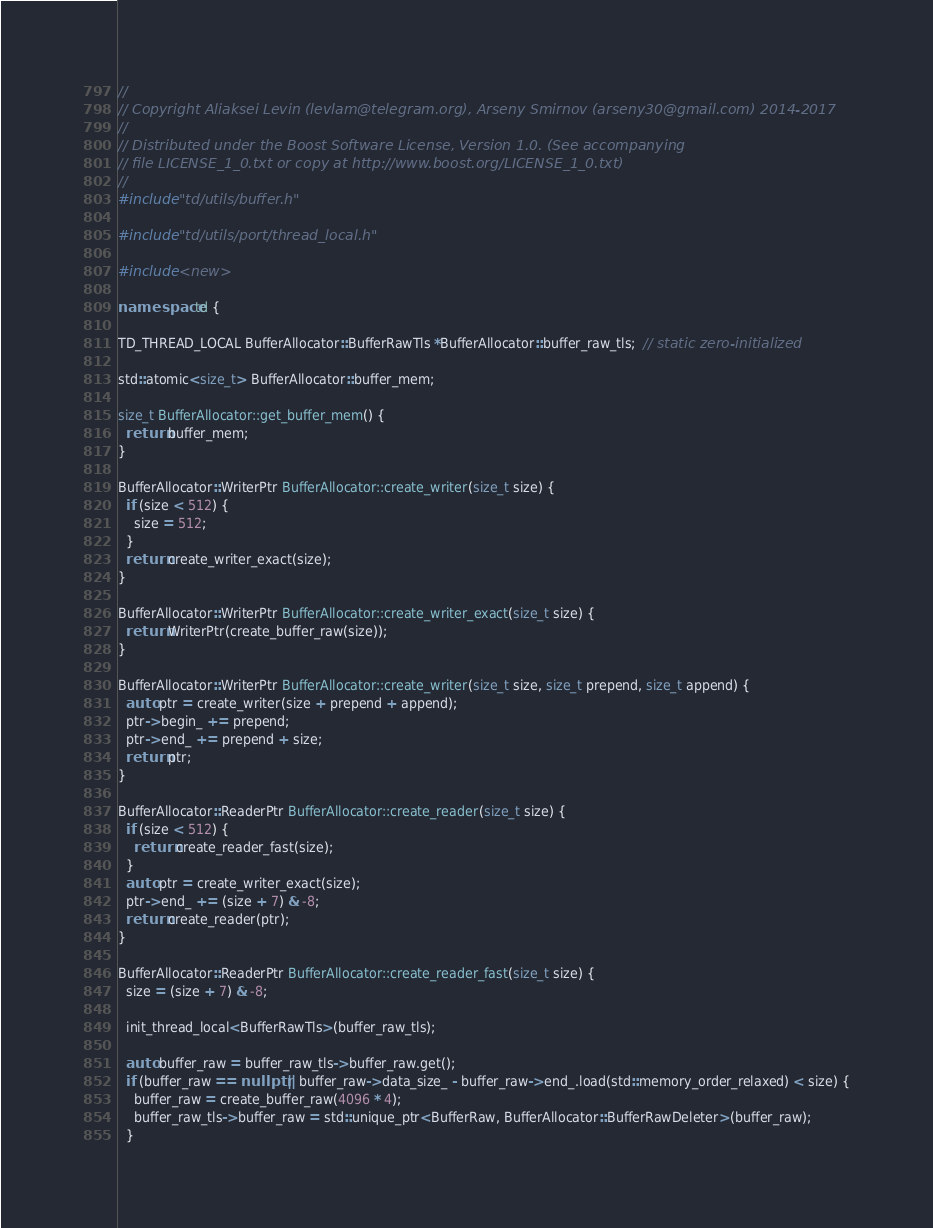Convert code to text. <code><loc_0><loc_0><loc_500><loc_500><_C++_>//
// Copyright Aliaksei Levin (levlam@telegram.org), Arseny Smirnov (arseny30@gmail.com) 2014-2017
//
// Distributed under the Boost Software License, Version 1.0. (See accompanying
// file LICENSE_1_0.txt or copy at http://www.boost.org/LICENSE_1_0.txt)
//
#include "td/utils/buffer.h"

#include "td/utils/port/thread_local.h"

#include <new>

namespace td {

TD_THREAD_LOCAL BufferAllocator::BufferRawTls *BufferAllocator::buffer_raw_tls;  // static zero-initialized

std::atomic<size_t> BufferAllocator::buffer_mem;

size_t BufferAllocator::get_buffer_mem() {
  return buffer_mem;
}

BufferAllocator::WriterPtr BufferAllocator::create_writer(size_t size) {
  if (size < 512) {
    size = 512;
  }
  return create_writer_exact(size);
}

BufferAllocator::WriterPtr BufferAllocator::create_writer_exact(size_t size) {
  return WriterPtr(create_buffer_raw(size));
}

BufferAllocator::WriterPtr BufferAllocator::create_writer(size_t size, size_t prepend, size_t append) {
  auto ptr = create_writer(size + prepend + append);
  ptr->begin_ += prepend;
  ptr->end_ += prepend + size;
  return ptr;
}

BufferAllocator::ReaderPtr BufferAllocator::create_reader(size_t size) {
  if (size < 512) {
    return create_reader_fast(size);
  }
  auto ptr = create_writer_exact(size);
  ptr->end_ += (size + 7) & -8;
  return create_reader(ptr);
}

BufferAllocator::ReaderPtr BufferAllocator::create_reader_fast(size_t size) {
  size = (size + 7) & -8;

  init_thread_local<BufferRawTls>(buffer_raw_tls);

  auto buffer_raw = buffer_raw_tls->buffer_raw.get();
  if (buffer_raw == nullptr || buffer_raw->data_size_ - buffer_raw->end_.load(std::memory_order_relaxed) < size) {
    buffer_raw = create_buffer_raw(4096 * 4);
    buffer_raw_tls->buffer_raw = std::unique_ptr<BufferRaw, BufferAllocator::BufferRawDeleter>(buffer_raw);
  }</code> 